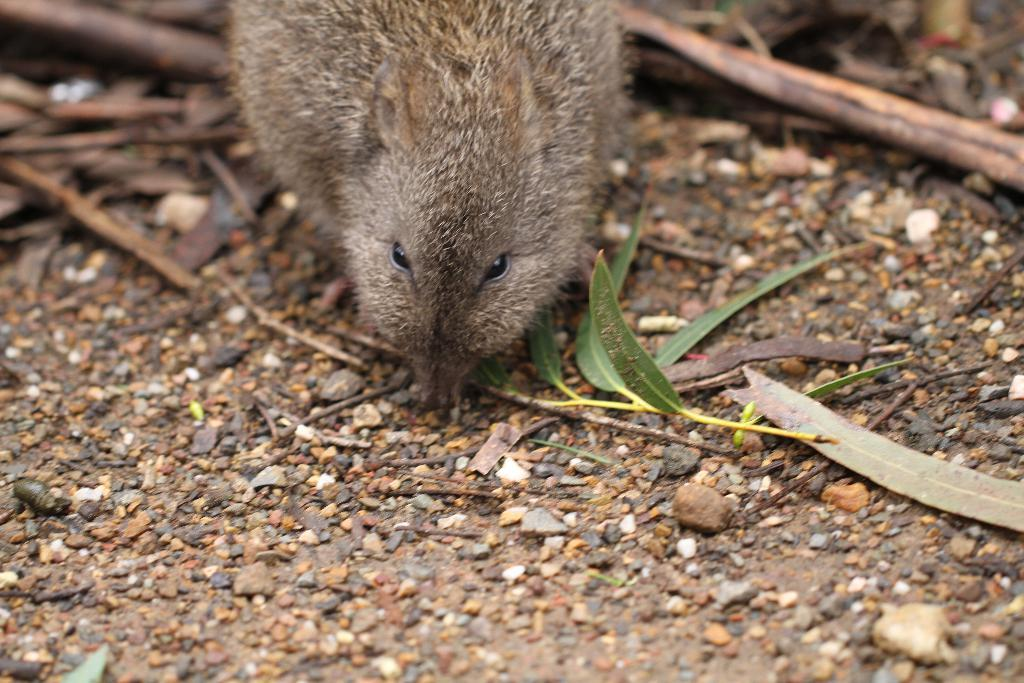What animal is on the ground in the image? There is a rat on the ground in the image. What natural materials can be seen in the image? There are sticks, leaves, and stones in the image. What position does the rat take when it is about to attack in the image? There is no indication in the image that the rat is about to attack or that it is in any specific position. 